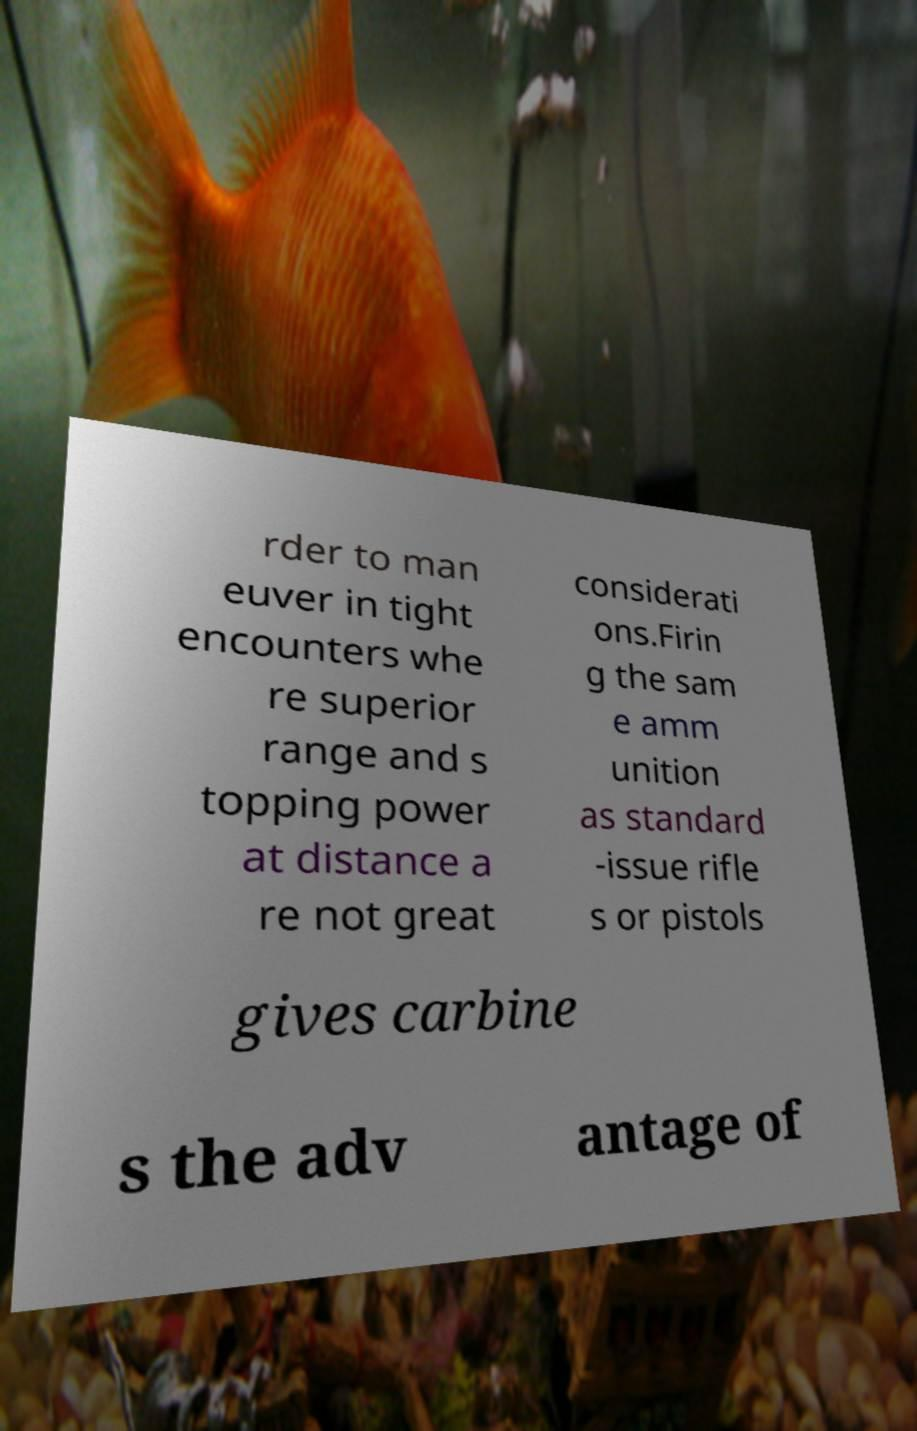What messages or text are displayed in this image? I need them in a readable, typed format. rder to man euver in tight encounters whe re superior range and s topping power at distance a re not great considerati ons.Firin g the sam e amm unition as standard -issue rifle s or pistols gives carbine s the adv antage of 